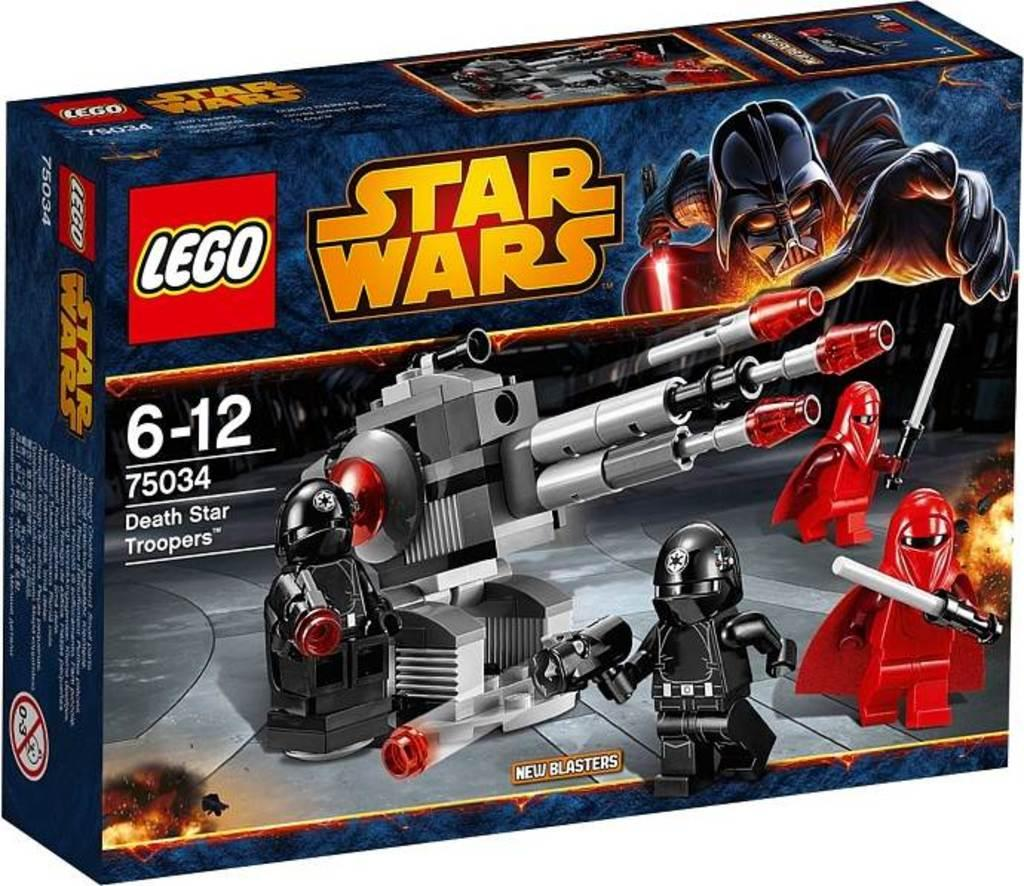<image>
Describe the image concisely. Box for some Star Wars toys showing some soldiers on the box. 